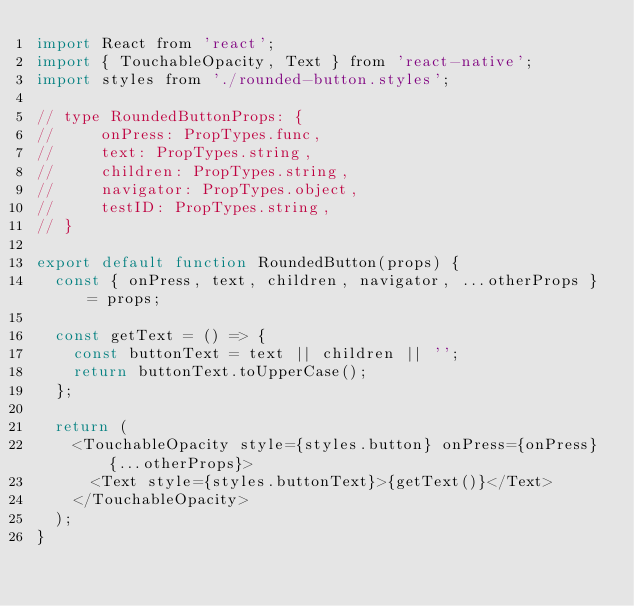<code> <loc_0><loc_0><loc_500><loc_500><_JavaScript_>import React from 'react';
import { TouchableOpacity, Text } from 'react-native';
import styles from './rounded-button.styles';

// type RoundedButtonProps: {
//     onPress: PropTypes.func,
//     text: PropTypes.string,
//     children: PropTypes.string,
//     navigator: PropTypes.object,
//     testID: PropTypes.string,
// }

export default function RoundedButton(props) {
  const { onPress, text, children, navigator, ...otherProps } = props;

  const getText = () => {
    const buttonText = text || children || '';
    return buttonText.toUpperCase();
  };

  return (
    <TouchableOpacity style={styles.button} onPress={onPress} {...otherProps}>
      <Text style={styles.buttonText}>{getText()}</Text>
    </TouchableOpacity>
  );
}
</code> 